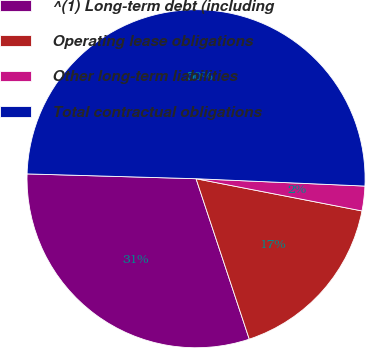Convert chart. <chart><loc_0><loc_0><loc_500><loc_500><pie_chart><fcel>^(1) Long-term debt (including<fcel>Operating lease obligations<fcel>Other long-term liabilities<fcel>Total contractual obligations<nl><fcel>30.55%<fcel>16.85%<fcel>2.36%<fcel>50.24%<nl></chart> 